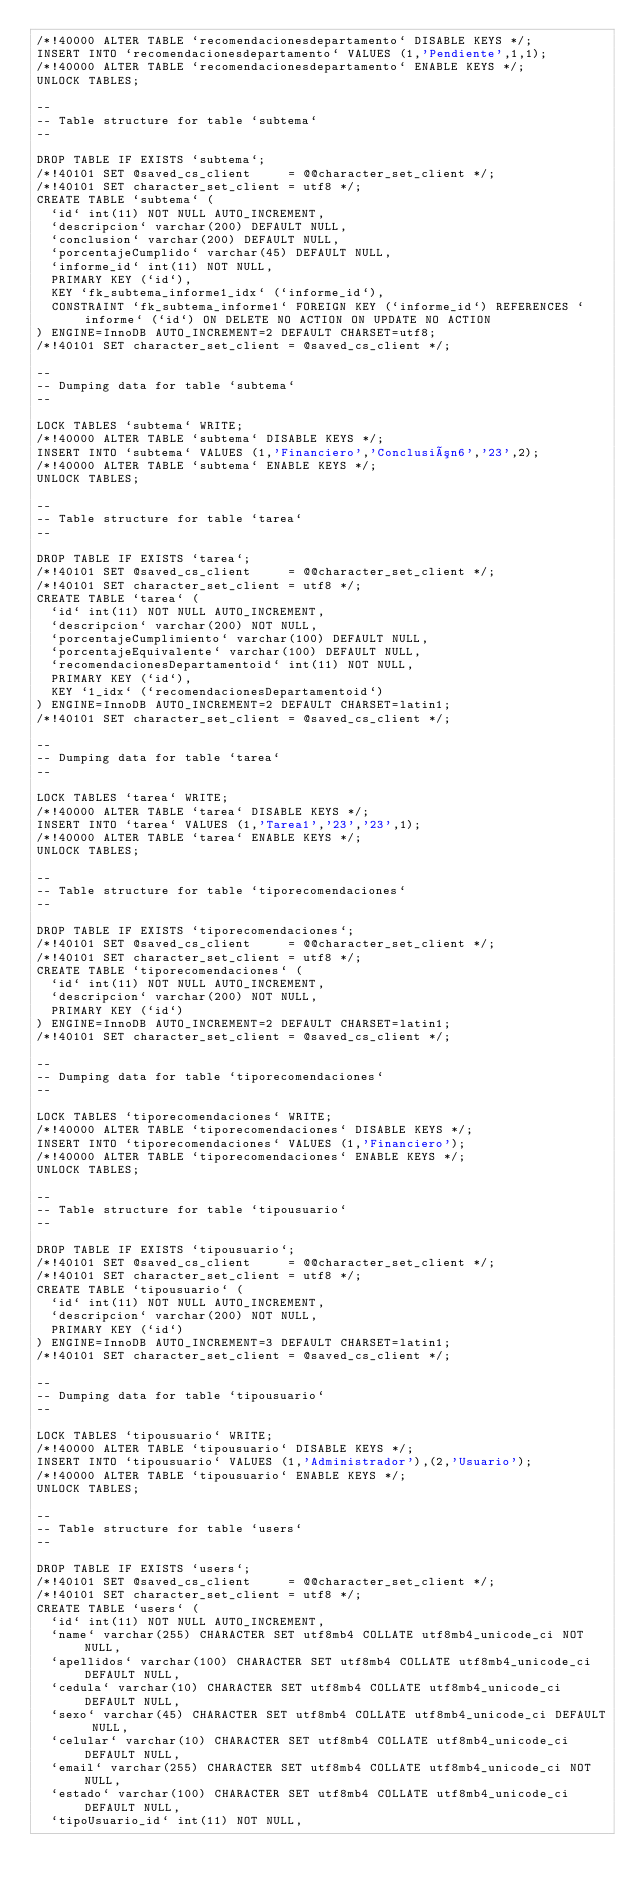<code> <loc_0><loc_0><loc_500><loc_500><_SQL_>/*!40000 ALTER TABLE `recomendacionesdepartamento` DISABLE KEYS */;
INSERT INTO `recomendacionesdepartamento` VALUES (1,'Pendiente',1,1);
/*!40000 ALTER TABLE `recomendacionesdepartamento` ENABLE KEYS */;
UNLOCK TABLES;

--
-- Table structure for table `subtema`
--

DROP TABLE IF EXISTS `subtema`;
/*!40101 SET @saved_cs_client     = @@character_set_client */;
/*!40101 SET character_set_client = utf8 */;
CREATE TABLE `subtema` (
  `id` int(11) NOT NULL AUTO_INCREMENT,
  `descripcion` varchar(200) DEFAULT NULL,
  `conclusion` varchar(200) DEFAULT NULL,
  `porcentajeCumplido` varchar(45) DEFAULT NULL,
  `informe_id` int(11) NOT NULL,
  PRIMARY KEY (`id`),
  KEY `fk_subtema_informe1_idx` (`informe_id`),
  CONSTRAINT `fk_subtema_informe1` FOREIGN KEY (`informe_id`) REFERENCES `informe` (`id`) ON DELETE NO ACTION ON UPDATE NO ACTION
) ENGINE=InnoDB AUTO_INCREMENT=2 DEFAULT CHARSET=utf8;
/*!40101 SET character_set_client = @saved_cs_client */;

--
-- Dumping data for table `subtema`
--

LOCK TABLES `subtema` WRITE;
/*!40000 ALTER TABLE `subtema` DISABLE KEYS */;
INSERT INTO `subtema` VALUES (1,'Financiero','Conclusión6','23',2);
/*!40000 ALTER TABLE `subtema` ENABLE KEYS */;
UNLOCK TABLES;

--
-- Table structure for table `tarea`
--

DROP TABLE IF EXISTS `tarea`;
/*!40101 SET @saved_cs_client     = @@character_set_client */;
/*!40101 SET character_set_client = utf8 */;
CREATE TABLE `tarea` (
  `id` int(11) NOT NULL AUTO_INCREMENT,
  `descripcion` varchar(200) NOT NULL,
  `porcentajeCumplimiento` varchar(100) DEFAULT NULL,
  `porcentajeEquivalente` varchar(100) DEFAULT NULL,
  `recomendacionesDepartamentoid` int(11) NOT NULL,
  PRIMARY KEY (`id`),
  KEY `1_idx` (`recomendacionesDepartamentoid`)
) ENGINE=InnoDB AUTO_INCREMENT=2 DEFAULT CHARSET=latin1;
/*!40101 SET character_set_client = @saved_cs_client */;

--
-- Dumping data for table `tarea`
--

LOCK TABLES `tarea` WRITE;
/*!40000 ALTER TABLE `tarea` DISABLE KEYS */;
INSERT INTO `tarea` VALUES (1,'Tarea1','23','23',1);
/*!40000 ALTER TABLE `tarea` ENABLE KEYS */;
UNLOCK TABLES;

--
-- Table structure for table `tiporecomendaciones`
--

DROP TABLE IF EXISTS `tiporecomendaciones`;
/*!40101 SET @saved_cs_client     = @@character_set_client */;
/*!40101 SET character_set_client = utf8 */;
CREATE TABLE `tiporecomendaciones` (
  `id` int(11) NOT NULL AUTO_INCREMENT,
  `descripcion` varchar(200) NOT NULL,
  PRIMARY KEY (`id`)
) ENGINE=InnoDB AUTO_INCREMENT=2 DEFAULT CHARSET=latin1;
/*!40101 SET character_set_client = @saved_cs_client */;

--
-- Dumping data for table `tiporecomendaciones`
--

LOCK TABLES `tiporecomendaciones` WRITE;
/*!40000 ALTER TABLE `tiporecomendaciones` DISABLE KEYS */;
INSERT INTO `tiporecomendaciones` VALUES (1,'Financiero');
/*!40000 ALTER TABLE `tiporecomendaciones` ENABLE KEYS */;
UNLOCK TABLES;

--
-- Table structure for table `tipousuario`
--

DROP TABLE IF EXISTS `tipousuario`;
/*!40101 SET @saved_cs_client     = @@character_set_client */;
/*!40101 SET character_set_client = utf8 */;
CREATE TABLE `tipousuario` (
  `id` int(11) NOT NULL AUTO_INCREMENT,
  `descripcion` varchar(200) NOT NULL,
  PRIMARY KEY (`id`)
) ENGINE=InnoDB AUTO_INCREMENT=3 DEFAULT CHARSET=latin1;
/*!40101 SET character_set_client = @saved_cs_client */;

--
-- Dumping data for table `tipousuario`
--

LOCK TABLES `tipousuario` WRITE;
/*!40000 ALTER TABLE `tipousuario` DISABLE KEYS */;
INSERT INTO `tipousuario` VALUES (1,'Administrador'),(2,'Usuario');
/*!40000 ALTER TABLE `tipousuario` ENABLE KEYS */;
UNLOCK TABLES;

--
-- Table structure for table `users`
--

DROP TABLE IF EXISTS `users`;
/*!40101 SET @saved_cs_client     = @@character_set_client */;
/*!40101 SET character_set_client = utf8 */;
CREATE TABLE `users` (
  `id` int(11) NOT NULL AUTO_INCREMENT,
  `name` varchar(255) CHARACTER SET utf8mb4 COLLATE utf8mb4_unicode_ci NOT NULL,
  `apellidos` varchar(100) CHARACTER SET utf8mb4 COLLATE utf8mb4_unicode_ci DEFAULT NULL,
  `cedula` varchar(10) CHARACTER SET utf8mb4 COLLATE utf8mb4_unicode_ci DEFAULT NULL,
  `sexo` varchar(45) CHARACTER SET utf8mb4 COLLATE utf8mb4_unicode_ci DEFAULT NULL,
  `celular` varchar(10) CHARACTER SET utf8mb4 COLLATE utf8mb4_unicode_ci DEFAULT NULL,
  `email` varchar(255) CHARACTER SET utf8mb4 COLLATE utf8mb4_unicode_ci NOT NULL,
  `estado` varchar(100) CHARACTER SET utf8mb4 COLLATE utf8mb4_unicode_ci DEFAULT NULL,
  `tipoUsuario_id` int(11) NOT NULL,</code> 